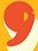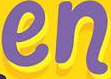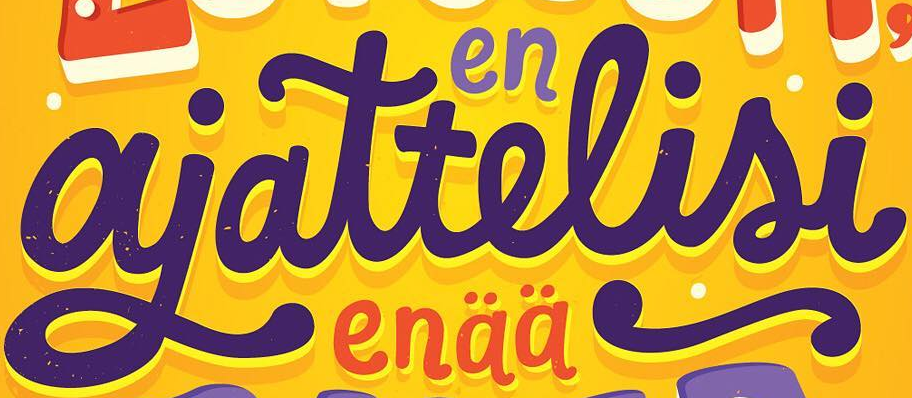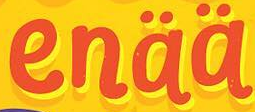Transcribe the words shown in these images in order, separated by a semicolon. ,; en; ajattelisi; enää 